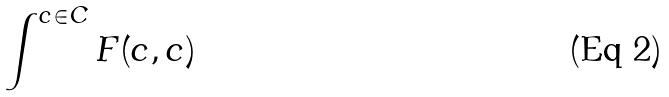Convert formula to latex. <formula><loc_0><loc_0><loc_500><loc_500>\int ^ { c \in C } F ( c , c )</formula> 